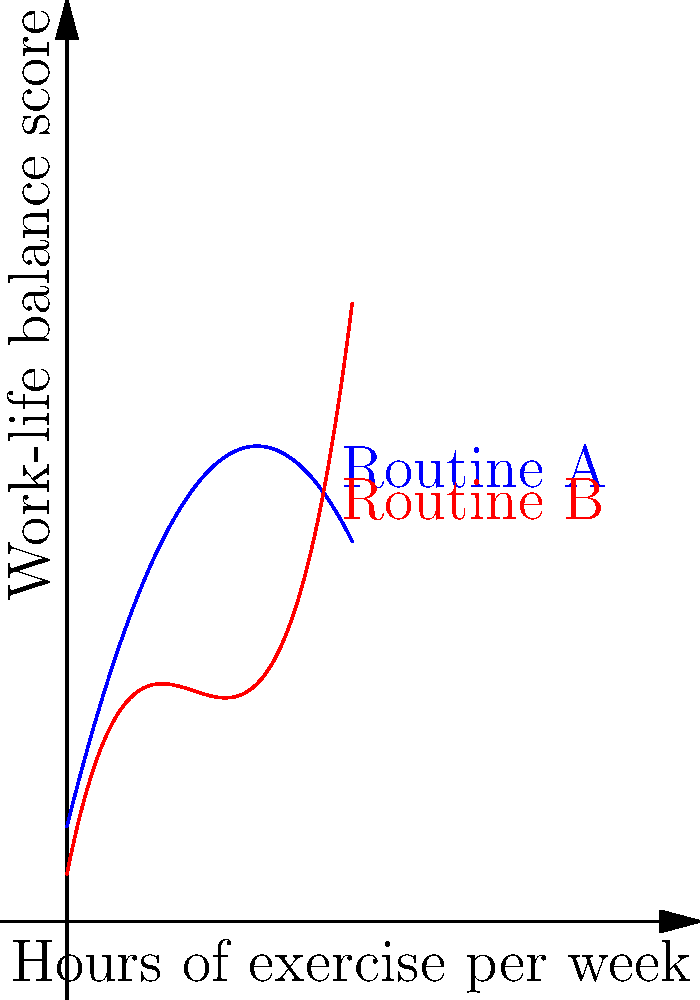The graph shows two polynomial curves representing the relationship between hours of exercise per week and work-life balance scores for two different exercise routines. Routine A is represented by a quadratic function, while Routine B is represented by a cubic function. At which point do the two routines yield the same work-life balance score, and what is that score? To solve this problem, we need to follow these steps:

1. Identify the equations of the two curves:
   Routine A: $f_1(x) = -0.5x^2 + 4x + 2$
   Routine B: $f_2(x) = 0.25x^3 - 2x^2 + 5x + 1$

2. To find where the routines yield the same score, we need to find the intersection point of these curves. This means solving the equation:
   $f_1(x) = f_2(x)$

3. Substitute the equations:
   $-0.5x^2 + 4x + 2 = 0.25x^3 - 2x^2 + 5x + 1$

4. Rearrange the equation:
   $0.25x^3 - 1.5x^2 + x - 1 = 0$

5. This is a cubic equation. By inspection or using a graphing calculator, we can see that $x = 2$ is a solution.

6. Verify by substituting $x = 2$ into both original equations:
   $f_1(2) = -0.5(2)^2 + 4(2) + 2 = -2 + 8 + 2 = 8$
   $f_2(2) = 0.25(2)^3 - 2(2)^2 + 5(2) + 1 = 2 - 8 + 10 + 1 = 5$

7. The work-life balance score at this point is 8.

Therefore, the two routines yield the same work-life balance score when 2 hours of exercise per week are performed, and the score at this point is 8.
Answer: (2, 8) 